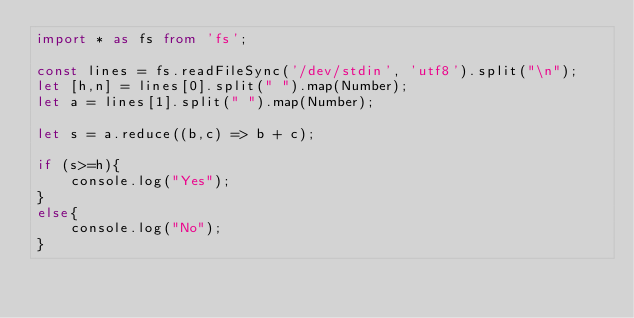Convert code to text. <code><loc_0><loc_0><loc_500><loc_500><_TypeScript_>import * as fs from 'fs';
 
const lines = fs.readFileSync('/dev/stdin', 'utf8').split("\n");
let [h,n] = lines[0].split(" ").map(Number);
let a = lines[1].split(" ").map(Number);

let s = a.reduce((b,c) => b + c);

if (s>=h){
    console.log("Yes");
}
else{
    console.log("No");
}
</code> 